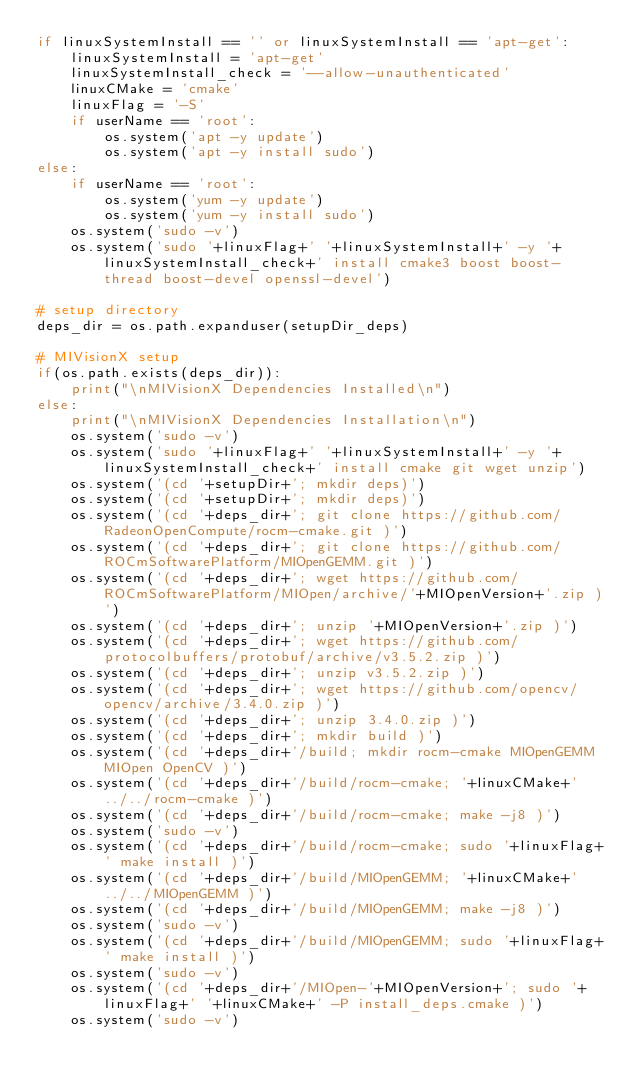<code> <loc_0><loc_0><loc_500><loc_500><_Python_>if linuxSystemInstall == '' or linuxSystemInstall == 'apt-get':
	linuxSystemInstall = 'apt-get'
	linuxSystemInstall_check = '--allow-unauthenticated'
	linuxCMake = 'cmake'
	linuxFlag = '-S'
	if userName == 'root':
		os.system('apt -y update')
		os.system('apt -y install sudo')
else:
	if userName == 'root':
		os.system('yum -y update')
		os.system('yum -y install sudo')
	os.system('sudo -v')
	os.system('sudo '+linuxFlag+' '+linuxSystemInstall+' -y '+linuxSystemInstall_check+' install cmake3 boost boost-thread boost-devel openssl-devel')

# setup directory
deps_dir = os.path.expanduser(setupDir_deps)

# MIVisionX setup
if(os.path.exists(deps_dir)):
	print("\nMIVisionX Dependencies Installed\n")
else:
	print("\nMIVisionX Dependencies Installation\n")
	os.system('sudo -v')
	os.system('sudo '+linuxFlag+' '+linuxSystemInstall+' -y '+linuxSystemInstall_check+' install cmake git wget unzip')
	os.system('(cd '+setupDir+'; mkdir deps)')
	os.system('(cd '+setupDir+'; mkdir deps)')
	os.system('(cd '+deps_dir+'; git clone https://github.com/RadeonOpenCompute/rocm-cmake.git )')
	os.system('(cd '+deps_dir+'; git clone https://github.com/ROCmSoftwarePlatform/MIOpenGEMM.git )')
	os.system('(cd '+deps_dir+'; wget https://github.com/ROCmSoftwarePlatform/MIOpen/archive/'+MIOpenVersion+'.zip )')
	os.system('(cd '+deps_dir+'; unzip '+MIOpenVersion+'.zip )')
	os.system('(cd '+deps_dir+'; wget https://github.com/protocolbuffers/protobuf/archive/v3.5.2.zip )')
	os.system('(cd '+deps_dir+'; unzip v3.5.2.zip )')
	os.system('(cd '+deps_dir+'; wget https://github.com/opencv/opencv/archive/3.4.0.zip )')
	os.system('(cd '+deps_dir+'; unzip 3.4.0.zip )')
	os.system('(cd '+deps_dir+'; mkdir build )')
	os.system('(cd '+deps_dir+'/build; mkdir rocm-cmake MIOpenGEMM MIOpen OpenCV )')
	os.system('(cd '+deps_dir+'/build/rocm-cmake; '+linuxCMake+' ../../rocm-cmake )')
	os.system('(cd '+deps_dir+'/build/rocm-cmake; make -j8 )')
	os.system('sudo -v')
	os.system('(cd '+deps_dir+'/build/rocm-cmake; sudo '+linuxFlag+' make install )')
	os.system('(cd '+deps_dir+'/build/MIOpenGEMM; '+linuxCMake+' ../../MIOpenGEMM )')
	os.system('(cd '+deps_dir+'/build/MIOpenGEMM; make -j8 )')
	os.system('sudo -v')
	os.system('(cd '+deps_dir+'/build/MIOpenGEMM; sudo '+linuxFlag+' make install )')
	os.system('sudo -v')
	os.system('(cd '+deps_dir+'/MIOpen-'+MIOpenVersion+'; sudo '+linuxFlag+' '+linuxCMake+' -P install_deps.cmake )')
	os.system('sudo -v')</code> 